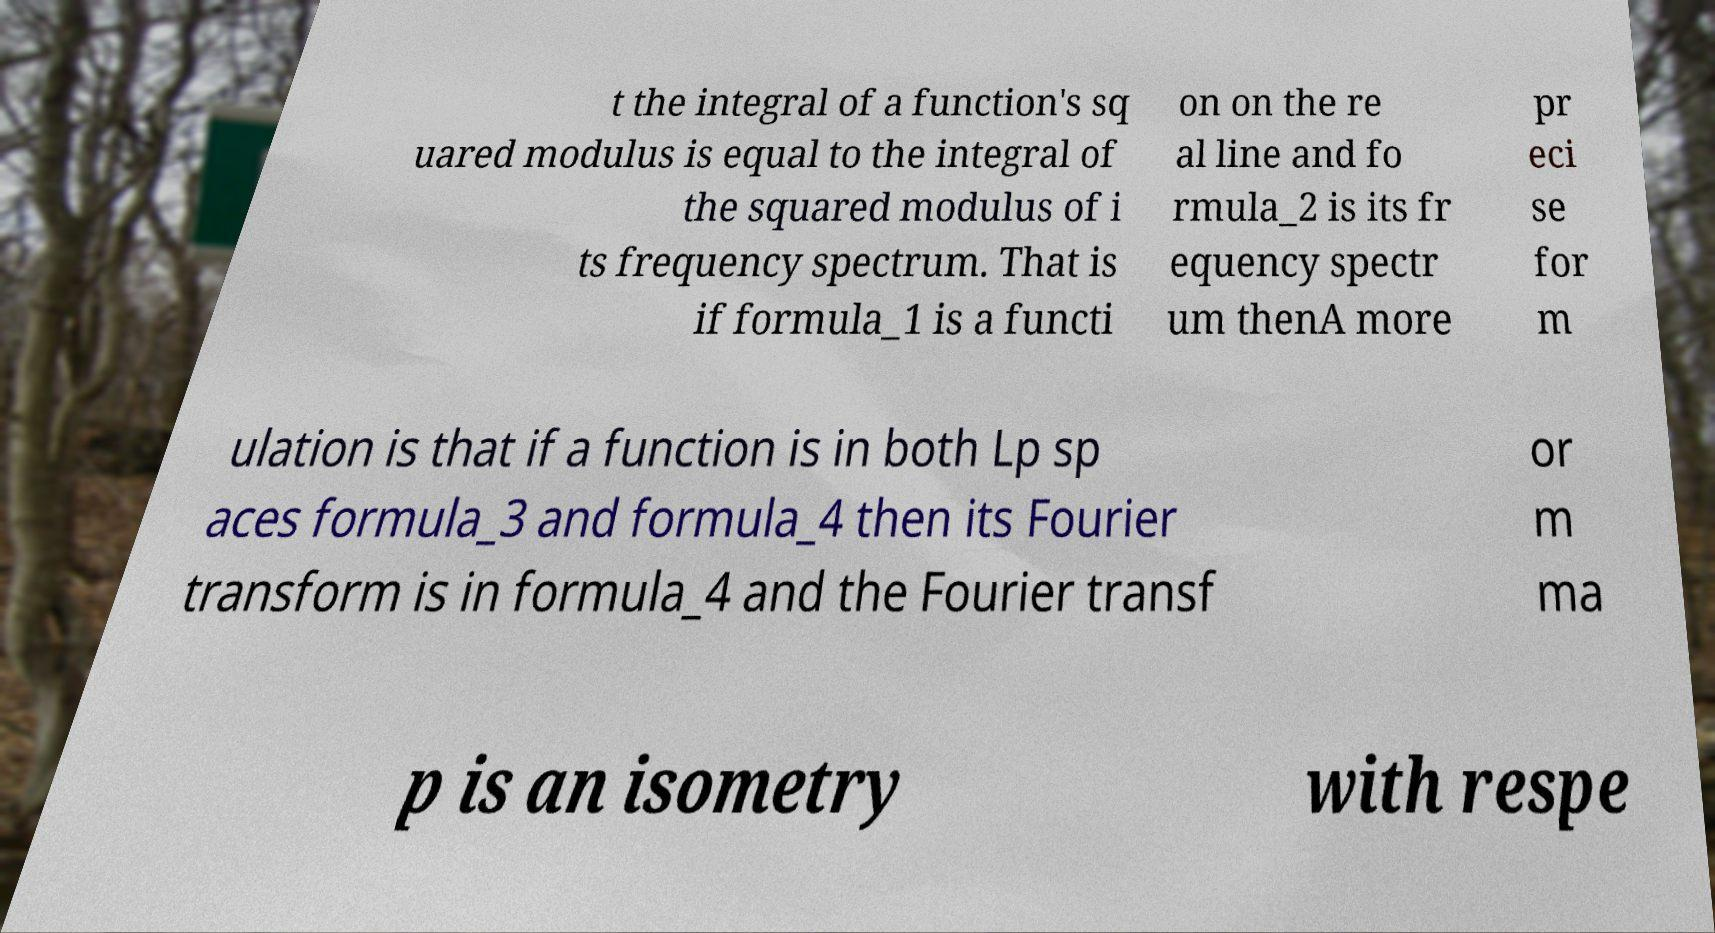I need the written content from this picture converted into text. Can you do that? t the integral of a function's sq uared modulus is equal to the integral of the squared modulus of i ts frequency spectrum. That is if formula_1 is a functi on on the re al line and fo rmula_2 is its fr equency spectr um thenA more pr eci se for m ulation is that if a function is in both Lp sp aces formula_3 and formula_4 then its Fourier transform is in formula_4 and the Fourier transf or m ma p is an isometry with respe 